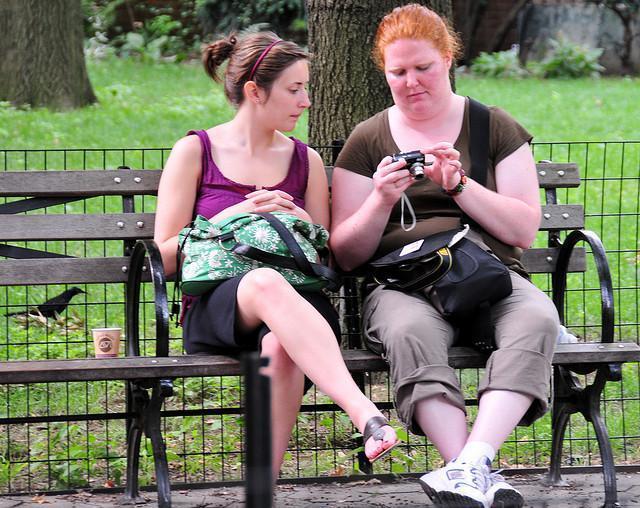How many people are there?
Give a very brief answer. 2. How many handbags are in the picture?
Give a very brief answer. 3. 